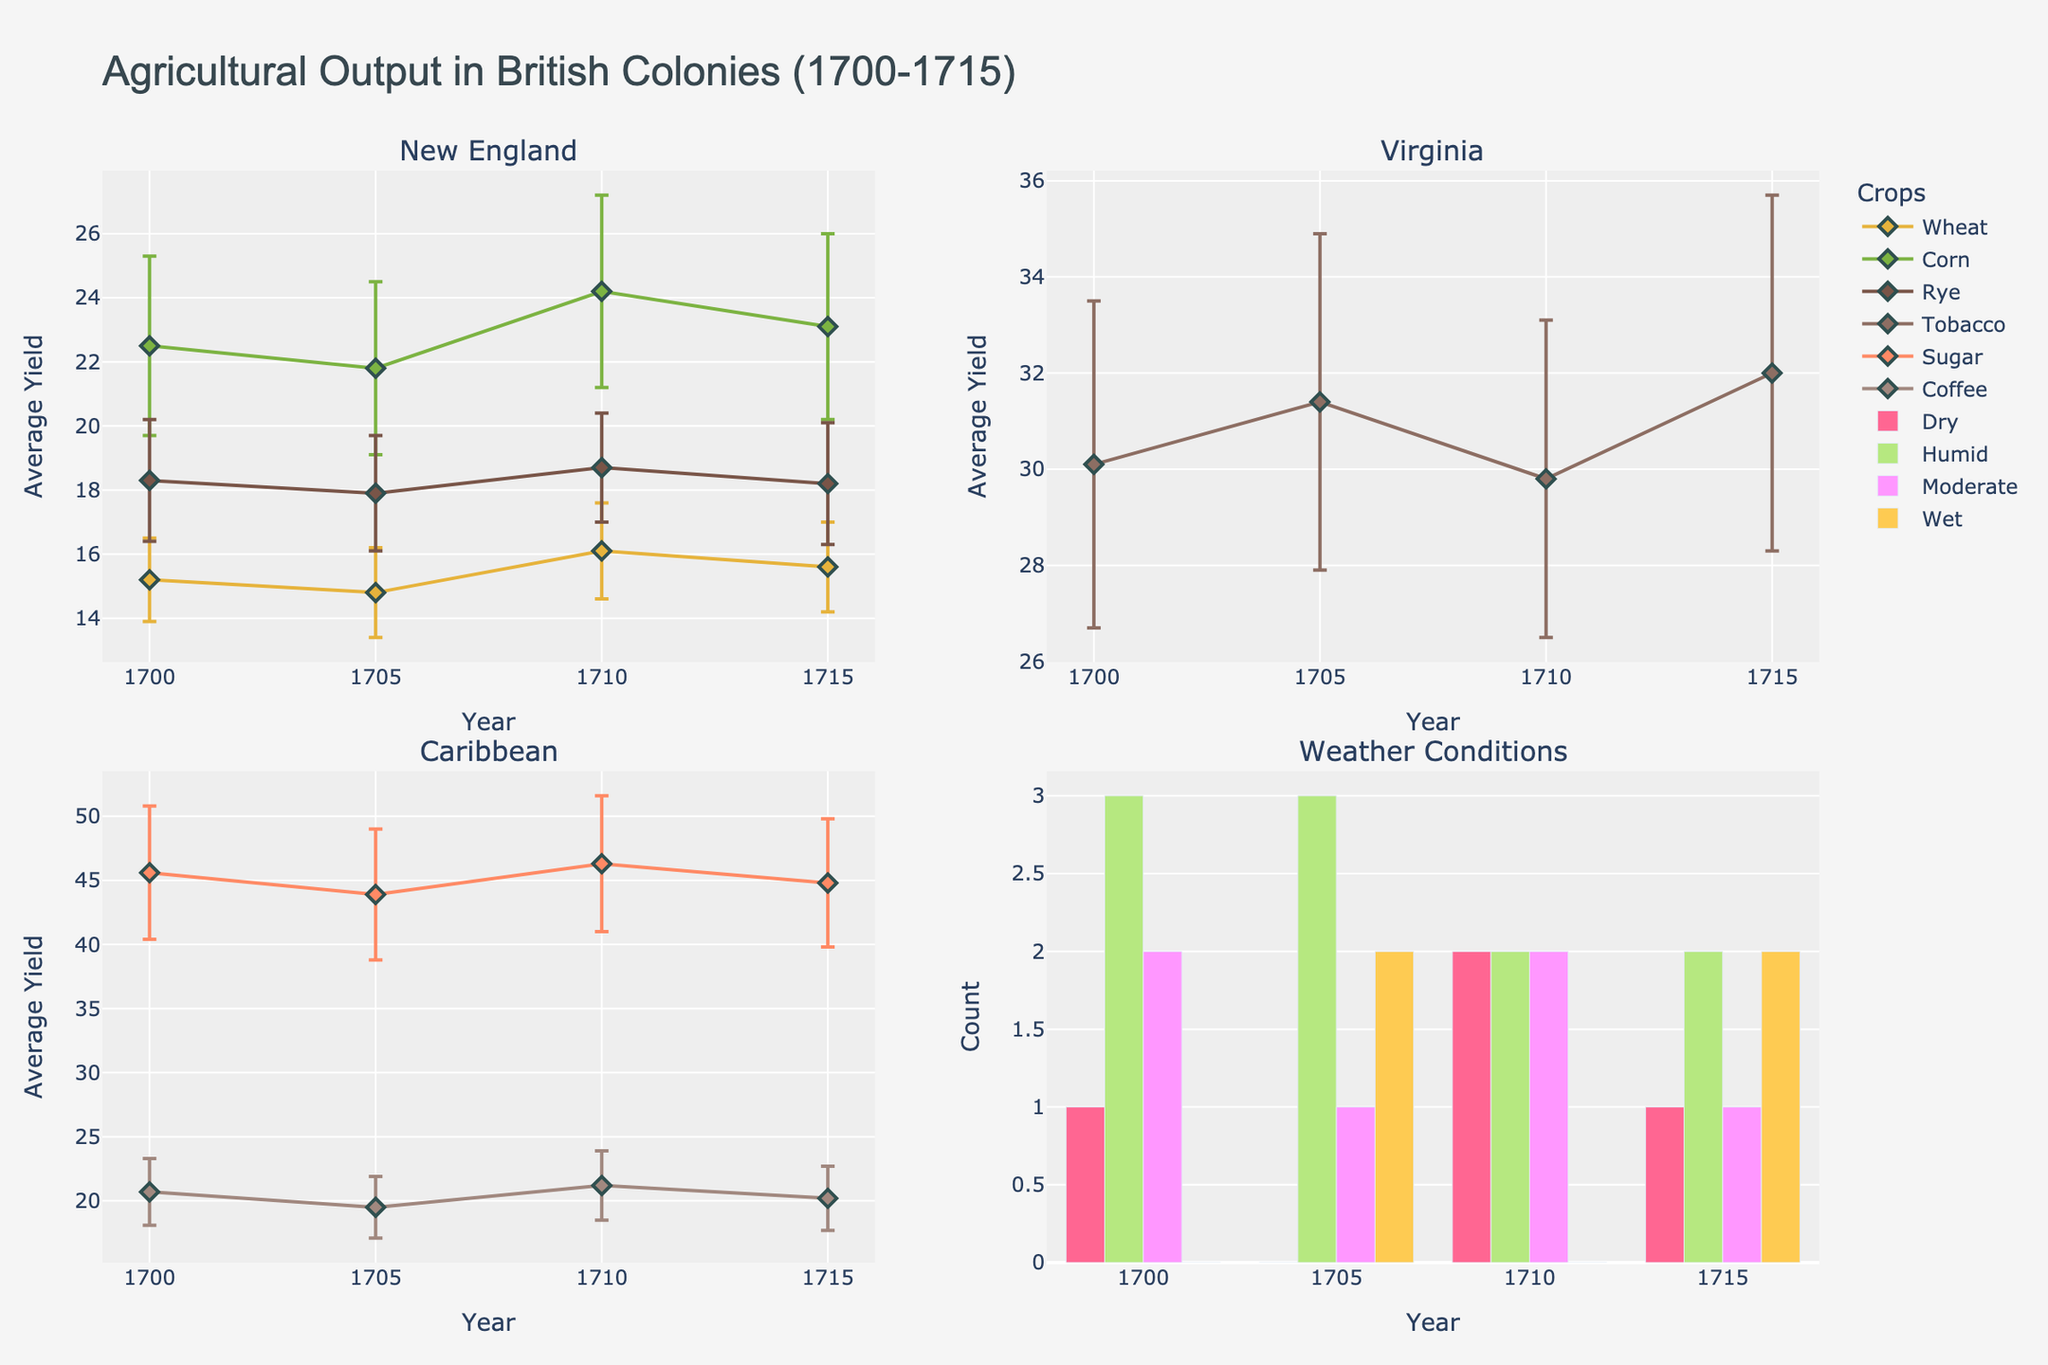Which crops are represented in the New England subplot? By inspecting the New England subplot, we can see the markers and lines for Wheat, Corn, and Rye, denoted by different colors and shapes.
Answer: Wheat, Corn, Rye What happens to the average yield of tobacco in Virginia from 1700 to 1715? By looking at the markers and lines for Tobacco in the Virginia subplot, we observe that the yield increases from 30.1 in 1700 to 32.0 in 1715 through a notable variation.
Answer: Increases Which weather condition has the highest occurrence between 1700 and 1715? In the Weather Conditions subplot (bar chart), the height of the bars represents the occurrences of each weather condition. Humid has the tallest bar across most years.
Answer: Humid What is the average yield of sugar in the Caribbean in 1710? By locating the year's point (1710) for Sugar in the Caribbean subplot, the marker indicates an average yield of 46.3.
Answer: 46.3 What is the percentage difference in the yield of Coffee in the Caribbean from 1705 to 1710? For Coffee in the Caribbean subplot, the yield changes from 19.5 in 1705 to 21.2 in 1710. The percentage difference = ((21.2 - 19.5) / 19.5) * 100.
Answer: 8.72% Comparing Rye in New England and Tobacco in Virginia, which one has a higher yield in 1705? By comparing the points for Rye in New England (17.9) and Tobacco in Virginia (31.4) for the year 1705, it is clear that Tobacco has a higher yield.
Answer: Tobacco in Virginia How does the standard deviation of Corn in New England compare to Sugar in the Caribbean in 1705? By examining the error bars for Corn (2.7) and Sugar (5.1) in the respective subplots for the year 1705, Sugar has a larger error bar, indicating a higher standard deviation.
Answer: Sugar is greater What are the trends for the yield of Wheat in New England over the presented years? By following the markers and lines for Wheat in New England from 1700 to 1715, the yield shows minor fluctuations but remains roughly stable between about 14.8 to 16.1.
Answer: Roughly stable Which crop shows the greatest variability in yield in the Caribbean subplot? By observing the size of the error bars in the Caribbean subplot, Sugar shows the greatest variability with the highest standard deviations.
Answer: Sugar 